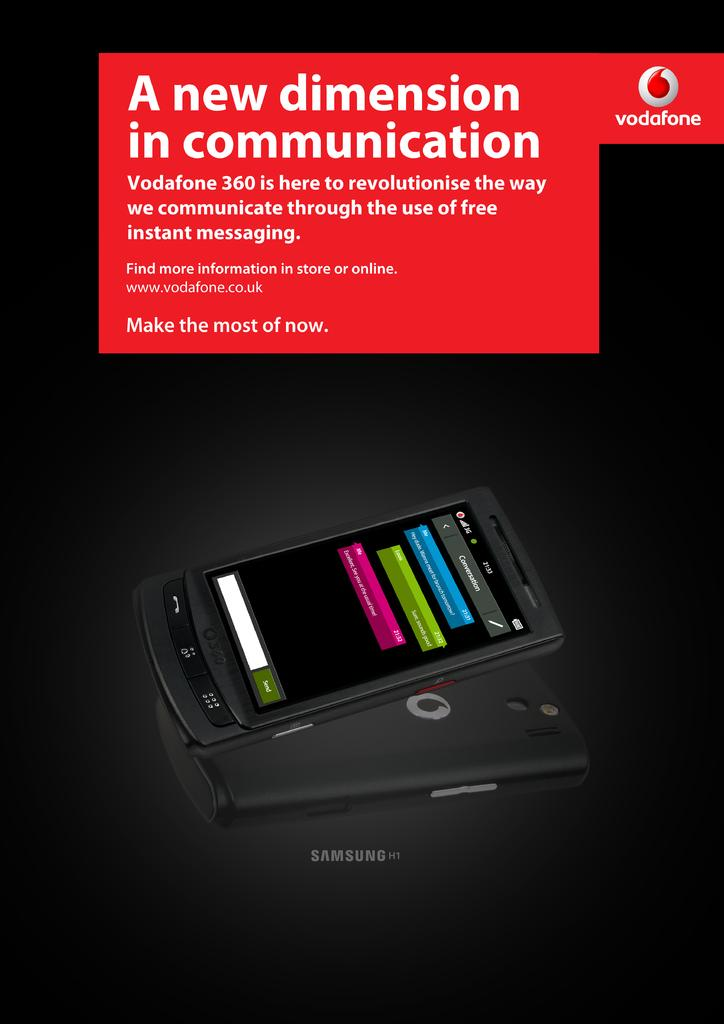<image>
Provide a brief description of the given image. An advertisement with a black background and a cell phone with script that say A new dimension in communication. 